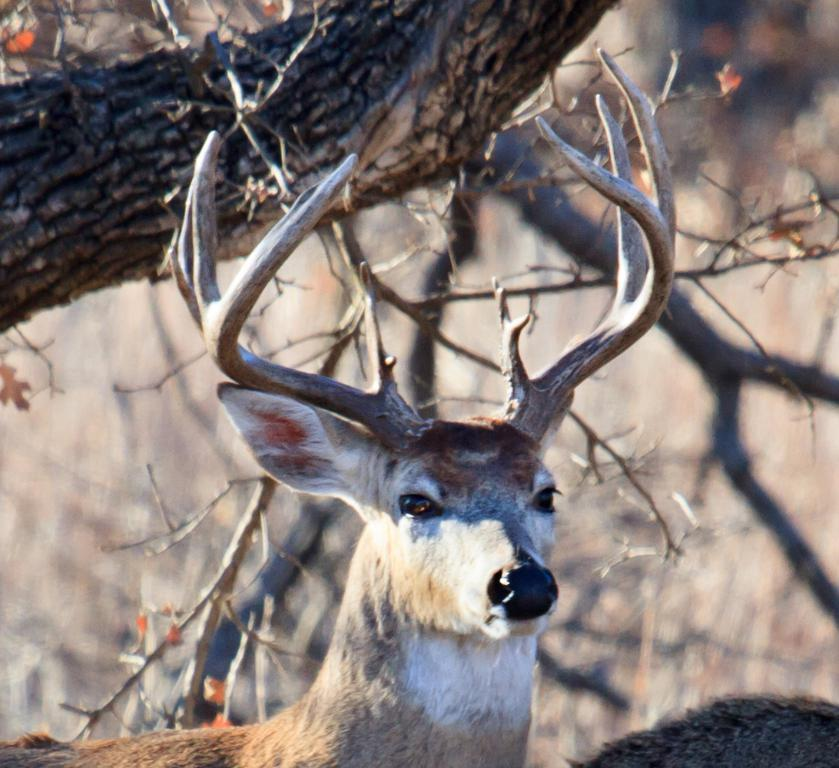What animal can be seen in the picture? There is a deer in the picture. What type of vegetation is present in the picture? There are trees in the picture. What invention is being demonstrated by the deer in the picture? There is no invention being demonstrated by the deer in the picture; it is simply a deer in its natural environment. 